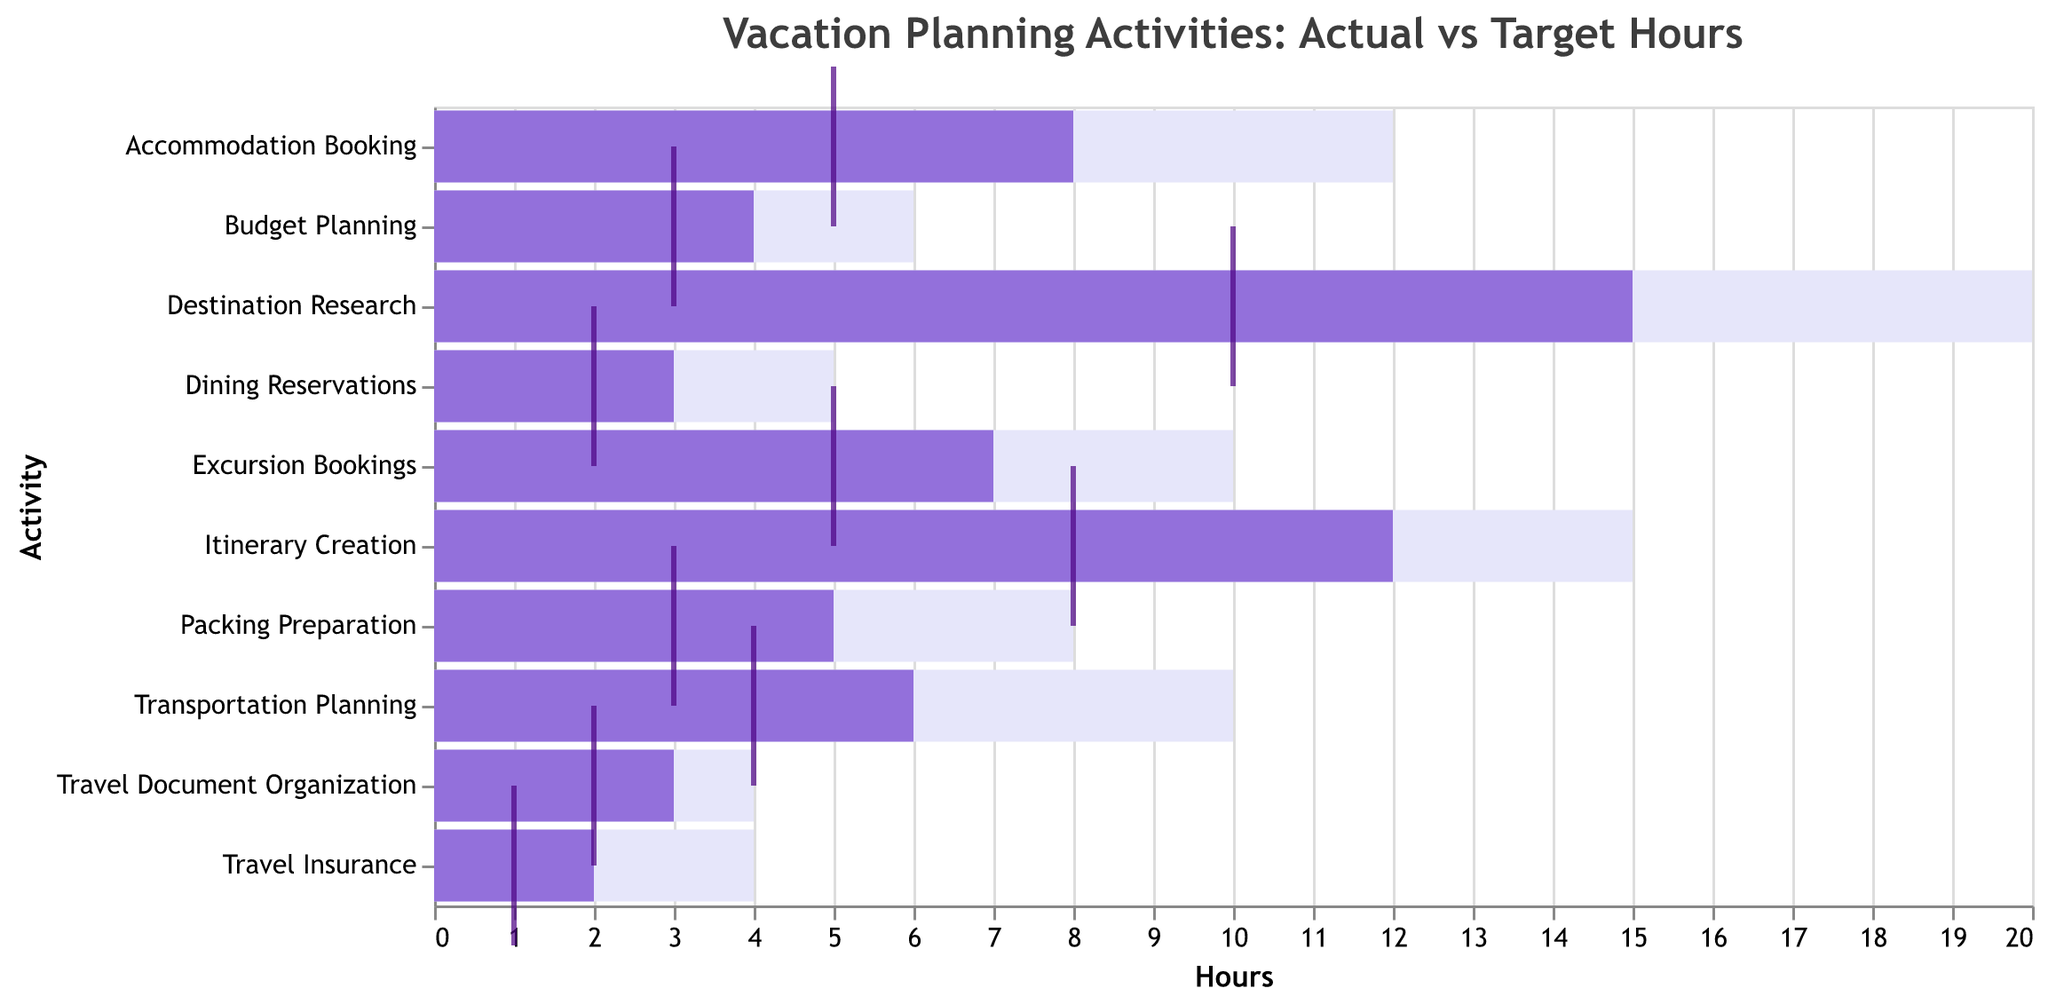What's the title of the figure? The title is usually at the top of the chart and tells us what the chart is about. In this case, it mentions both the topic (vacation planning activities) and what is being compared (actual vs. target hours).
Answer: Vacation Planning Activities: Actual vs Target Hours How many activities were analyzed in this chart? Counting the number of distinct bars for each activity within the chart provides the total number of analyzed activities.
Answer: 10 Which activity had the highest number of actual hours spent on it? Look for the longest purple bar which represents the actual hours dedicated to each activity. The longest bar indicates the highest value.
Answer: Destination Research Are there any activities where the actual hours spent met or exceeded the maximum hours? Compare the purple bars (Actual Hours) with the light lavender background bars (Maximum Hours). None of the purple bars exceed or even meet their respective light lavender background bars.
Answer: No Which activities spent more actual hours than the target hours? Identify activities where the length of the purple bar exceeds the position of the dark tick mark, which denotes the target hours. These activities are Destination Research, Accommodation Booking, Transportation Planning, Itinerary Creation, Packing Preparation, Excursion Bookings, Dining Reservations, and Travel Document Organization.
Answer: 8 activities How many hours over the target were spent on Itinerary Creation? Find the target hours (denoted by the dark tick) and subtract it from the actual hours (purple bar) for Itinerary Creation. Actual Hours = 12, Target Hours = 8, so the difference is 12 - 8.
Answer: 4 What's the combined total of actual hours spent on Budget Planning and Travel Insurance? Add the actual hours spent on Budget Planning (4) and Travel Insurance (2). Summing these values gives the total.
Answer: 6 For which activity are the actual hours closest to the target hours? Calculate the absolute difference between the actual hours and target hours for each activity and find the smallest difference. For Travel Document Organization: actual = 3, target = 2, difference = 1, which is the smallest.
Answer: Travel Document Organization Which activity has the lowest target hours? Look for the shortest dark tick on the chart, which represents the lowest target hours. In this case, it is Travel Insurance with 1 target hour.
Answer: Travel Insurance What is the difference between the actual hours and the maximum hours for Excursion Bookings? Look at the actual hours (purple bar) and subtract it from the maximum hours (light lavender background bar) for Excursion Bookings. Maximum Hours = 10, Actual Hours = 7, so the difference is 10 - 7.
Answer: 3 